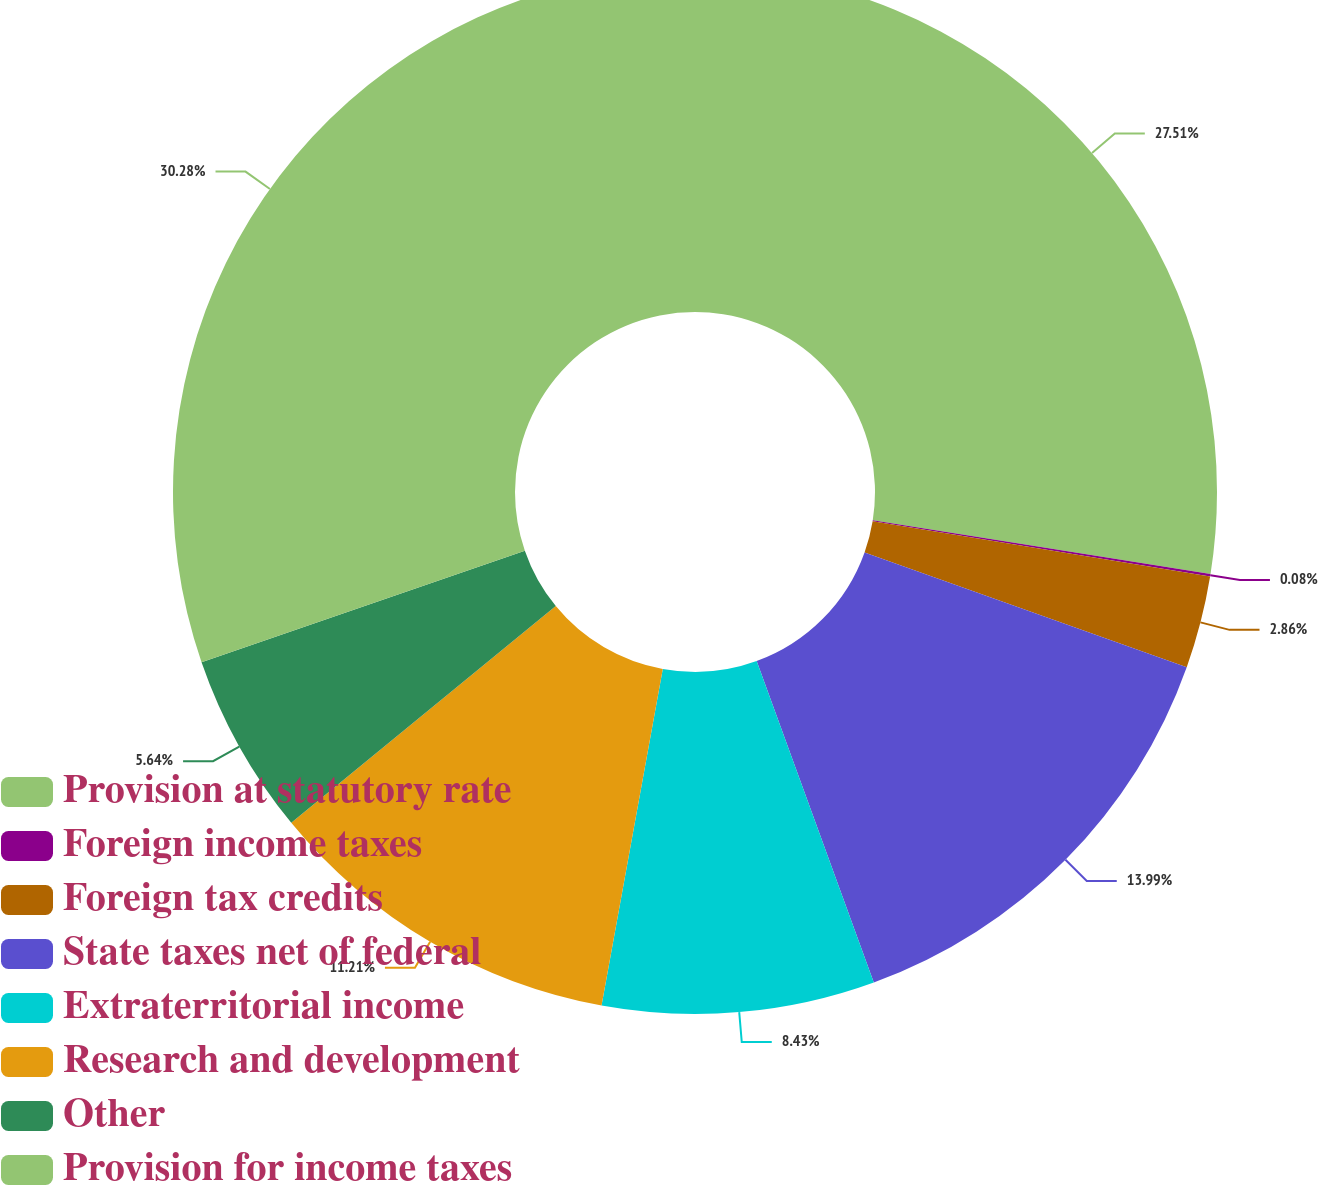<chart> <loc_0><loc_0><loc_500><loc_500><pie_chart><fcel>Provision at statutory rate<fcel>Foreign income taxes<fcel>Foreign tax credits<fcel>State taxes net of federal<fcel>Extraterritorial income<fcel>Research and development<fcel>Other<fcel>Provision for income taxes<nl><fcel>27.51%<fcel>0.08%<fcel>2.86%<fcel>13.99%<fcel>8.43%<fcel>11.21%<fcel>5.64%<fcel>30.29%<nl></chart> 